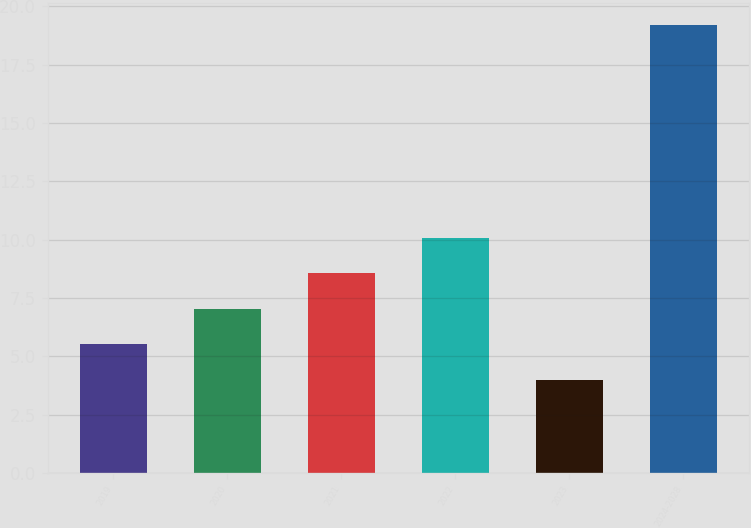Convert chart. <chart><loc_0><loc_0><loc_500><loc_500><bar_chart><fcel>2019<fcel>2020<fcel>2021<fcel>2022<fcel>2023<fcel>2024-2028<nl><fcel>5.52<fcel>7.04<fcel>8.56<fcel>10.08<fcel>4<fcel>19.2<nl></chart> 